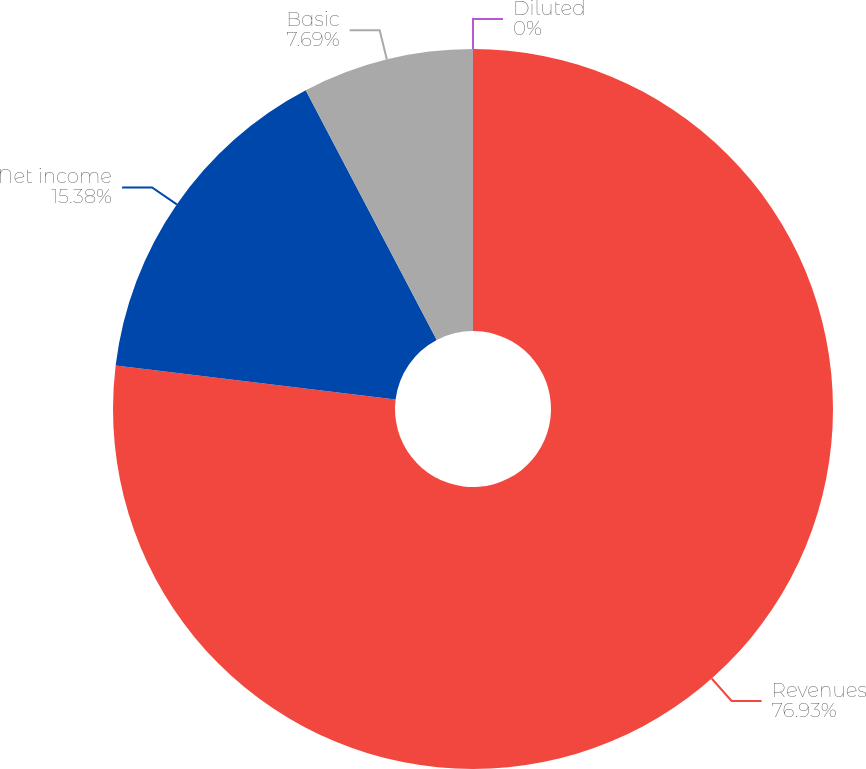Convert chart. <chart><loc_0><loc_0><loc_500><loc_500><pie_chart><fcel>Revenues<fcel>Net income<fcel>Basic<fcel>Diluted<nl><fcel>76.92%<fcel>15.38%<fcel>7.69%<fcel>0.0%<nl></chart> 